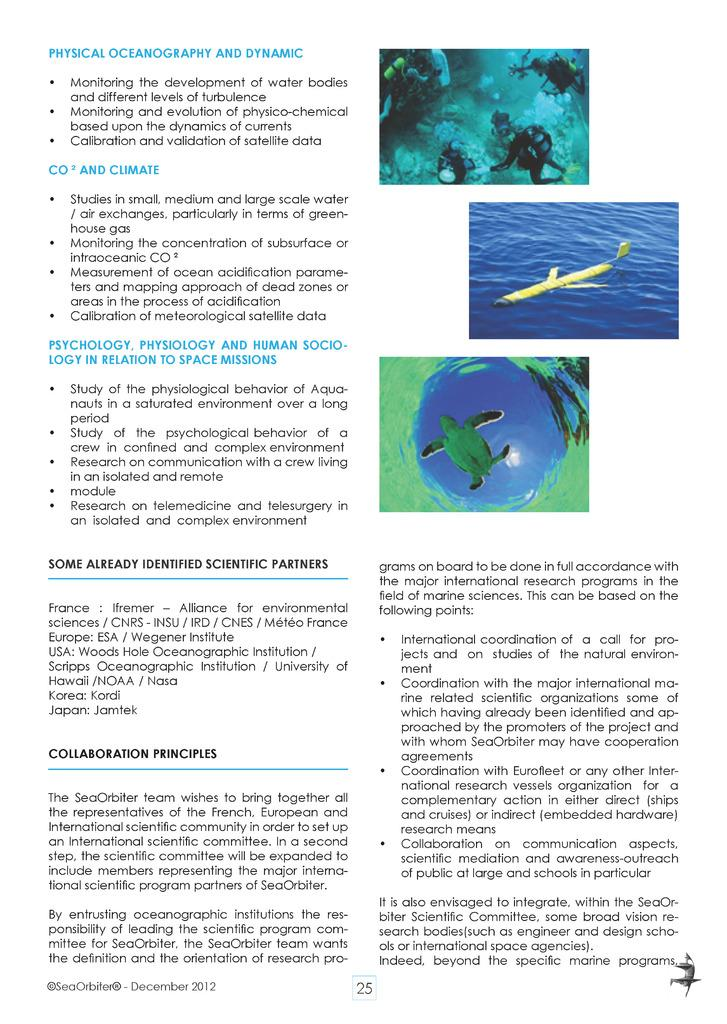What is present on the paper in the image? The paper has a topic printed on it. What colors are used for the printed topic on the paper? The printed topic uses blue and black colors. How many images of water are visible in the image? There are three images of water in the image. What reason does the team have for using a wing in the image? There is no team or wing present in the image; it only features a paper with a printed topic and images of water. 